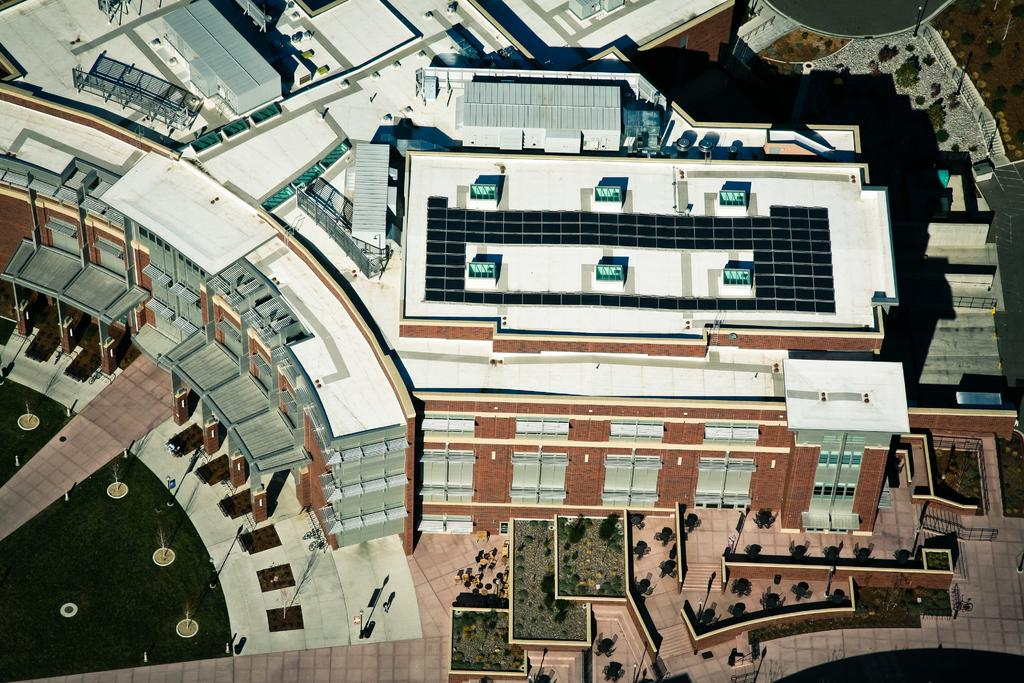What type of view is provided in the image? The image shows a top view of a building. What natural elements can be seen in the image? There are trees, plants, and bushes in the image. Are there any icicles hanging from the trees in the image? There are no icicles present in the image, as the trees and plants appear to be in a normal, non-frozen state. 